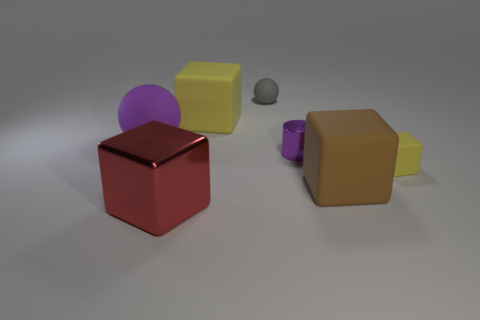How many things are either yellow things left of the purple metallic object or large matte blocks in front of the big purple matte sphere?
Provide a short and direct response. 2. Is there anything else that is the same shape as the red object?
Offer a terse response. Yes. How many large red metal things are there?
Provide a succinct answer. 1. Is there another purple thing of the same size as the purple rubber object?
Offer a very short reply. No. Is the brown cube made of the same material as the yellow cube behind the tiny yellow matte thing?
Ensure brevity in your answer.  Yes. Are there the same number of gray metallic cylinders and large red cubes?
Offer a terse response. No. There is a object that is left of the large red cube; what is its material?
Give a very brief answer. Rubber. How big is the brown matte object?
Provide a short and direct response. Large. There is a purple thing that is left of the metallic block; does it have the same size as the yellow rubber thing in front of the purple sphere?
Provide a succinct answer. No. The brown rubber thing that is the same shape as the big yellow rubber thing is what size?
Your answer should be compact. Large. 